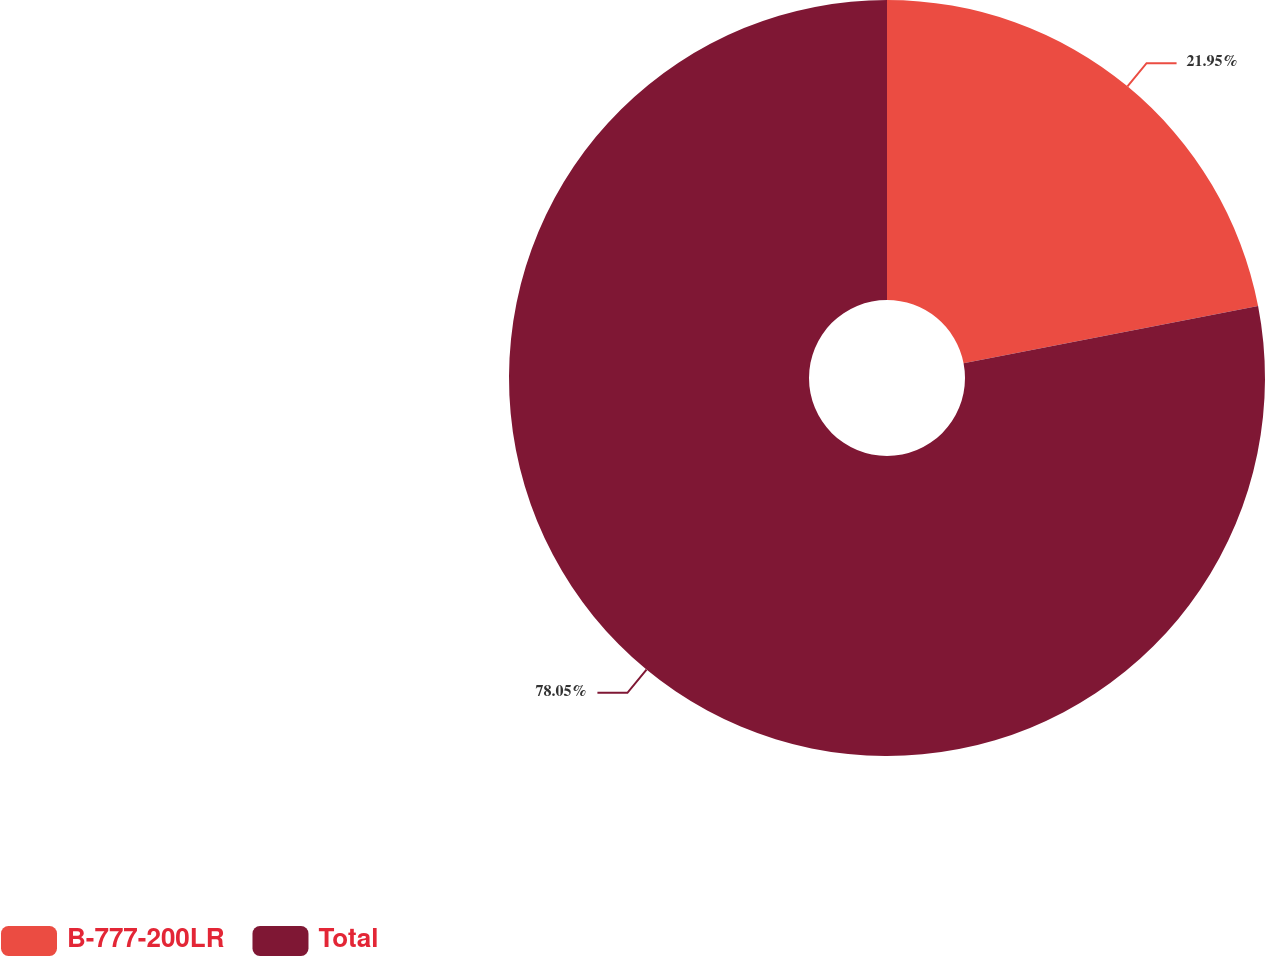Convert chart to OTSL. <chart><loc_0><loc_0><loc_500><loc_500><pie_chart><fcel>B-777-200LR<fcel>Total<nl><fcel>21.95%<fcel>78.05%<nl></chart> 